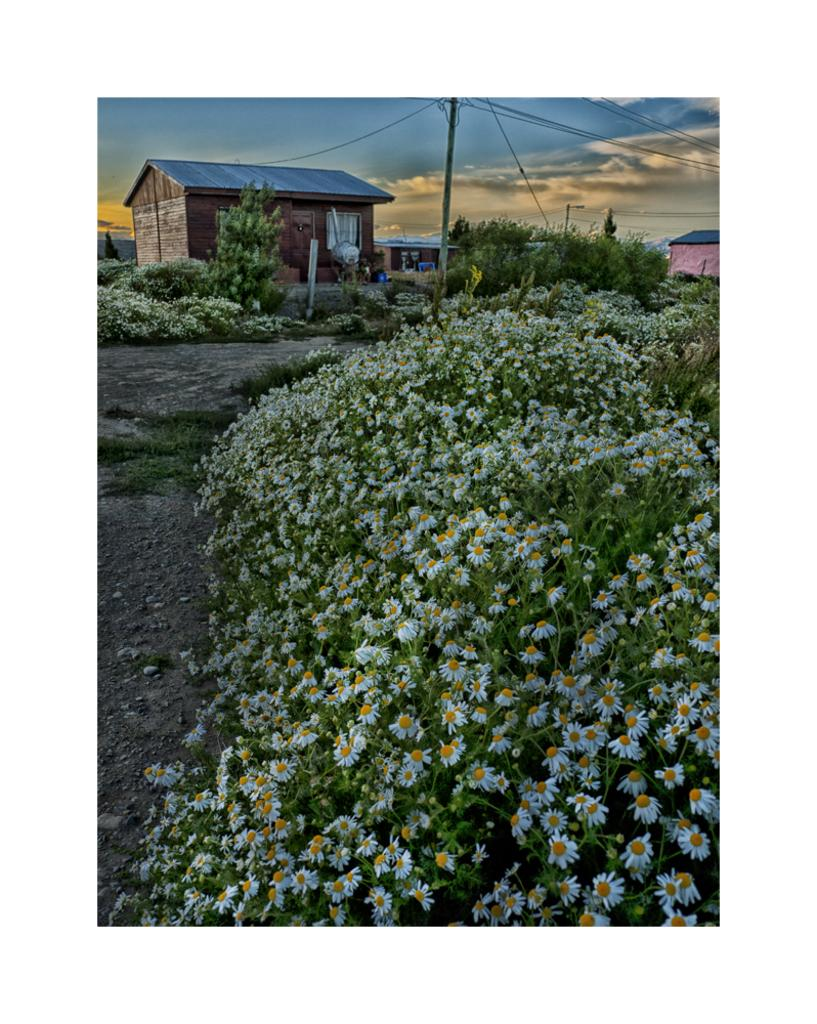What is located in the front of the image? There are flowers in the front of the image. What can be seen in the background of the image? There are houses, poles, and plants in the background of the image. What is the condition of the sky in the image? The sky is cloudy in the image. Can you hear the music being played by the snail in the image? There is no snail or music present in the image. How does the walkway look like in the image? There is no walkway mentioned in the provided facts, so it cannot be determined from the image. 